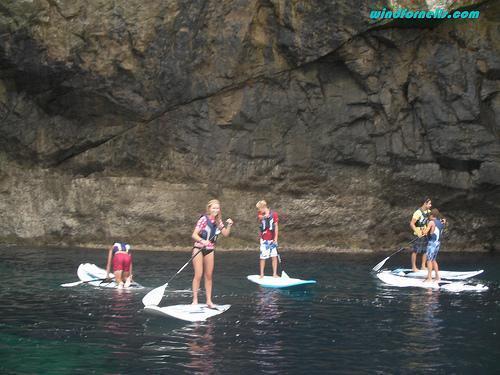How many people are in the picture?
Give a very brief answer. 5. 